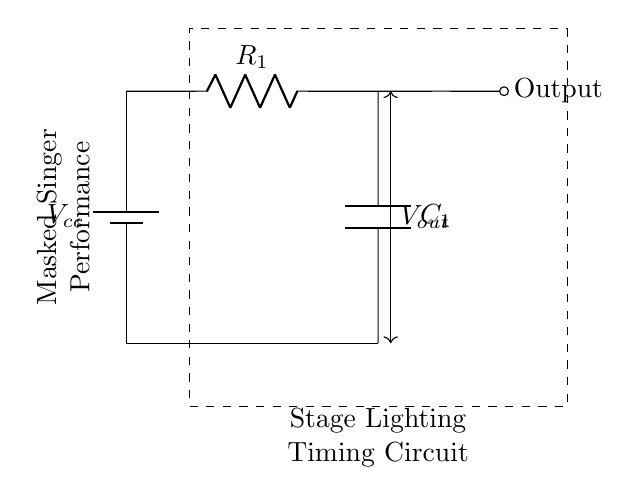What is the value of the resistor? The value of the resistor is indicated as R1 in the diagram, but the specific numerical value is not provided. Typically, you'd choose a value suitable for the timing characteristics desired in the circuit.
Answer: R1 What is the function of the capacitor in this circuit? The capacitor (C1) in this timing circuit stores electrical energy and releases it at a controlled rate, which helps define the timing for the lighting transitions during performances.
Answer: Timing What type of circuit is this? This circuit is a resistor-capacitor timing circuit, as it consists of a resistor and a capacitor that work together to control the time it takes for the output voltage to change.
Answer: Resistor-capacitor What is the output of this circuit? The output is taken from the junction of the resistor and the capacitor, represented in the circuit as the "Output" node and indicates the control signal for the stage lighting.
Answer: Output How does the resistor affect the timing? The resistor value directly influences the time constant of the circuit, which is calculated by the product of the resistance and capacitance, thus affecting how quickly the circuit charges or discharges.
Answer: Time constant What represents the input voltage? The input voltage is represented by Vcc in the diagram and provides power to the circuit for the operation of lighting control.
Answer: Vcc 